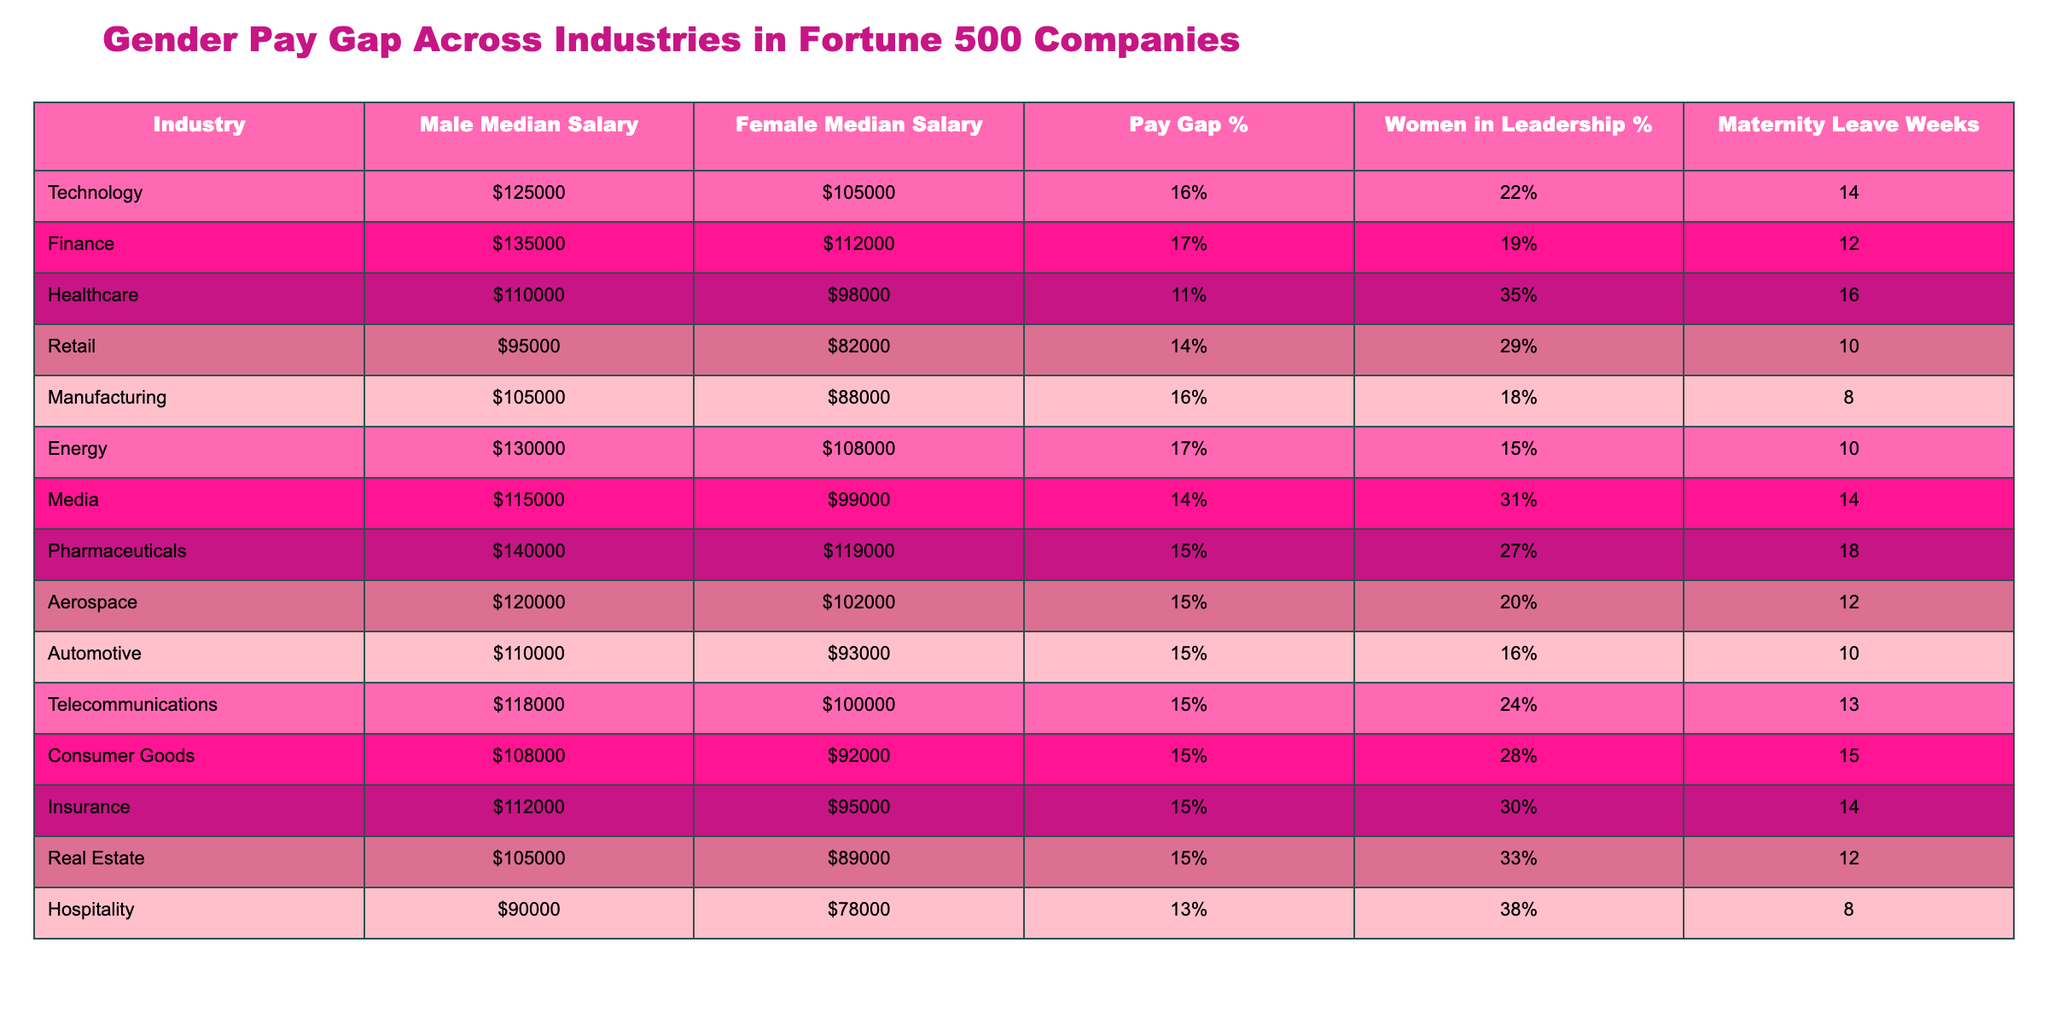What is the median salary for women in the healthcare industry? According to the table, the female median salary in the healthcare industry is $98,000.
Answer: $98,000 Which industry shows the largest gender pay gap? The largest gender pay gap is found in the finance industry, with a pay gap of 17%.
Answer: Finance What percentage of women hold leadership positions in the pharmaceutical industry? The table indicates that 27% of women hold leadership positions in the pharmaceutical industry.
Answer: 27% How many weeks of maternity leave do women in the retail industry receive? Women in the retail industry receive 10 weeks of maternity leave, as mentioned in the table.
Answer: 10 weeks Calculate the average male median salary across all industries listed. To find the average male median salary, sum the male median salaries: $125,000 + $135,000 + $110,000 + $95,000 + $105,000 + $130,000 + $115,000 + $140,000 + $120,000 + $110,000 + $118,000 + $108,000 + $112,000 + $105,000 + $90,000 = $1,711,000. There are 15 industries, so the average is $1,711,000 / 15 = $114,066.67, rounded to $114,067.
Answer: $114,067 Is the percentage of women in leadership positions higher in the hospitality industry than in the automotive industry? The hospitality industry has 38% of women in leadership positions, whereas the automotive industry has 16%. Thus, the hospitality industry does have a higher percentage of women in leadership.
Answer: Yes What is the difference in median salary for men and women in the telecommunications industry? The male median salary in telecommunications is $118,000 and the female median salary is $100,000. The difference is $118,000 - $100,000 = $18,000.
Answer: $18,000 What is the average maternity leave duration for women across all listed industries? To calculate the average, sum the maternity leave weeks: 14 + 12 + 16 + 10 + 8 + 10 + 14 + 18 + 12 + 10 + 13 + 15 + 14 + 12 + 8 = 203. Dividing by the number of industries (15) gives an average of 203 / 15 = 13.53 weeks, rounded to 14 weeks.
Answer: 14 weeks Do women in the energy industry earn less than women in the media industry? Women in the energy industry have a median salary of $108,000, while women in the media industry earn $99,000. Therefore, women in energy earn more than women in media.
Answer: No Which industry has the lowest female median salary? The retail industry has the lowest female median salary at $82,000, as seen in the table.
Answer: Retail If you combine the male median salaries of the top three industries (technology, finance, and pharmaceuticals), what would be the total? The male median salaries for technology ($125,000), finance ($135,000), and pharmaceuticals ($140,000) sum to $125,000 + $135,000 + $140,000 = $400,000.
Answer: $400,000 